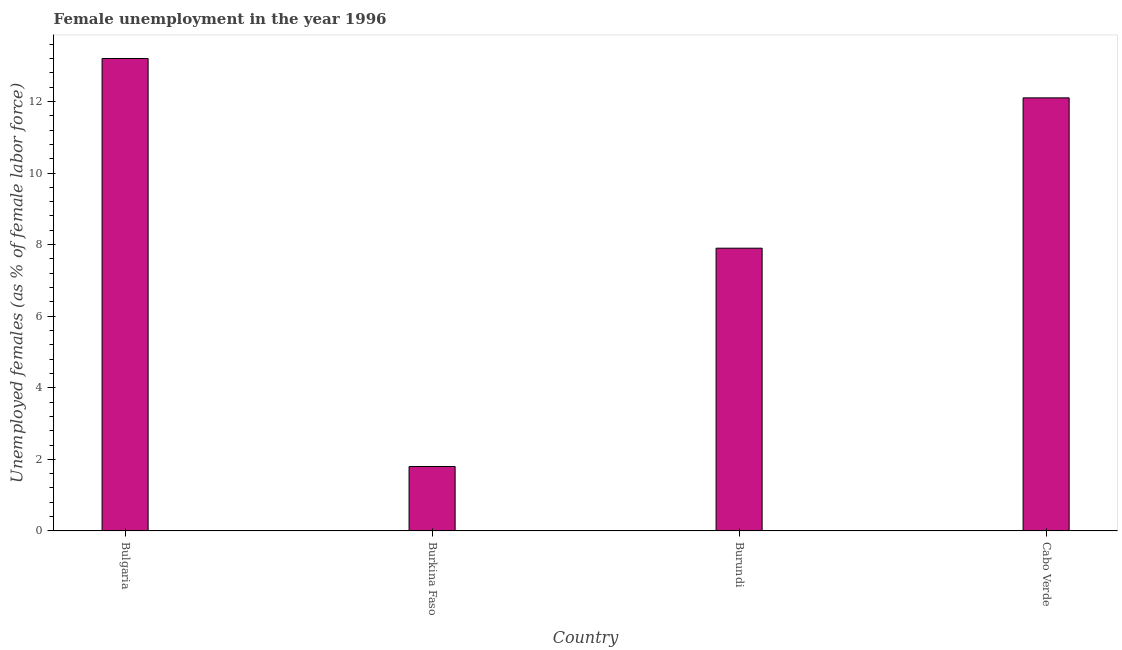Does the graph contain any zero values?
Your answer should be very brief. No. What is the title of the graph?
Provide a short and direct response. Female unemployment in the year 1996. What is the label or title of the Y-axis?
Keep it short and to the point. Unemployed females (as % of female labor force). What is the unemployed females population in Burundi?
Your answer should be compact. 7.9. Across all countries, what is the maximum unemployed females population?
Give a very brief answer. 13.2. Across all countries, what is the minimum unemployed females population?
Your answer should be very brief. 1.8. In which country was the unemployed females population minimum?
Give a very brief answer. Burkina Faso. What is the sum of the unemployed females population?
Your response must be concise. 35. What is the average unemployed females population per country?
Give a very brief answer. 8.75. What is the median unemployed females population?
Your answer should be very brief. 10. In how many countries, is the unemployed females population greater than 12.8 %?
Provide a short and direct response. 1. What is the ratio of the unemployed females population in Bulgaria to that in Cabo Verde?
Offer a terse response. 1.09. Is the unemployed females population in Bulgaria less than that in Burundi?
Keep it short and to the point. No. Is the difference between the unemployed females population in Bulgaria and Cabo Verde greater than the difference between any two countries?
Your answer should be compact. No. Is the sum of the unemployed females population in Bulgaria and Cabo Verde greater than the maximum unemployed females population across all countries?
Provide a short and direct response. Yes. In how many countries, is the unemployed females population greater than the average unemployed females population taken over all countries?
Give a very brief answer. 2. Are the values on the major ticks of Y-axis written in scientific E-notation?
Keep it short and to the point. No. What is the Unemployed females (as % of female labor force) in Bulgaria?
Your answer should be compact. 13.2. What is the Unemployed females (as % of female labor force) in Burkina Faso?
Keep it short and to the point. 1.8. What is the Unemployed females (as % of female labor force) of Burundi?
Make the answer very short. 7.9. What is the Unemployed females (as % of female labor force) of Cabo Verde?
Give a very brief answer. 12.1. What is the difference between the Unemployed females (as % of female labor force) in Bulgaria and Burkina Faso?
Provide a short and direct response. 11.4. What is the difference between the Unemployed females (as % of female labor force) in Bulgaria and Burundi?
Offer a very short reply. 5.3. What is the difference between the Unemployed females (as % of female labor force) in Burkina Faso and Cabo Verde?
Your answer should be compact. -10.3. What is the difference between the Unemployed females (as % of female labor force) in Burundi and Cabo Verde?
Offer a terse response. -4.2. What is the ratio of the Unemployed females (as % of female labor force) in Bulgaria to that in Burkina Faso?
Keep it short and to the point. 7.33. What is the ratio of the Unemployed females (as % of female labor force) in Bulgaria to that in Burundi?
Provide a short and direct response. 1.67. What is the ratio of the Unemployed females (as % of female labor force) in Bulgaria to that in Cabo Verde?
Keep it short and to the point. 1.09. What is the ratio of the Unemployed females (as % of female labor force) in Burkina Faso to that in Burundi?
Offer a terse response. 0.23. What is the ratio of the Unemployed females (as % of female labor force) in Burkina Faso to that in Cabo Verde?
Give a very brief answer. 0.15. What is the ratio of the Unemployed females (as % of female labor force) in Burundi to that in Cabo Verde?
Provide a short and direct response. 0.65. 